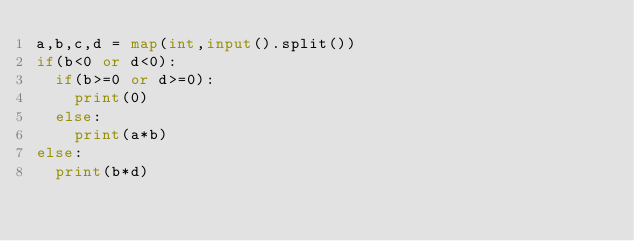<code> <loc_0><loc_0><loc_500><loc_500><_Python_>a,b,c,d = map(int,input().split())
if(b<0 or d<0):
  if(b>=0 or d>=0):
    print(0)
  else:
    print(a*b)
else:
  print(b*d)</code> 